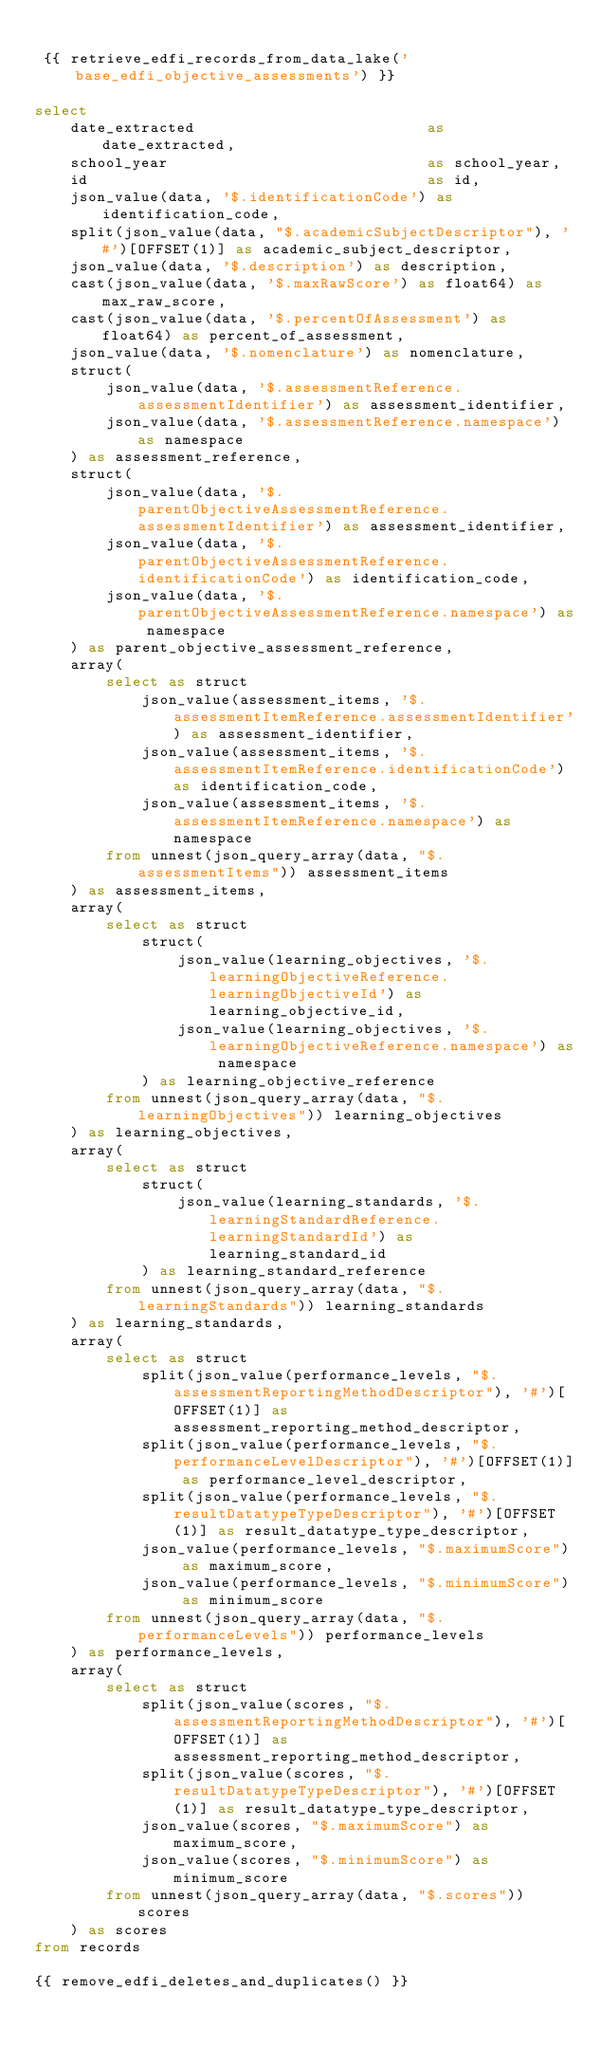Convert code to text. <code><loc_0><loc_0><loc_500><loc_500><_SQL_>
 {{ retrieve_edfi_records_from_data_lake('base_edfi_objective_assessments') }}

select
    date_extracted                          as date_extracted,
    school_year                             as school_year,
    id                                      as id,
    json_value(data, '$.identificationCode') as identification_code,
    split(json_value(data, "$.academicSubjectDescriptor"), '#')[OFFSET(1)] as academic_subject_descriptor,
    json_value(data, '$.description') as description,
    cast(json_value(data, '$.maxRawScore') as float64) as max_raw_score,
    cast(json_value(data, '$.percentOfAssessment') as float64) as percent_of_assessment,
    json_value(data, '$.nomenclature') as nomenclature,
    struct(
        json_value(data, '$.assessmentReference.assessmentIdentifier') as assessment_identifier,
        json_value(data, '$.assessmentReference.namespace') as namespace
    ) as assessment_reference,
    struct(
        json_value(data, '$.parentObjectiveAssessmentReference.assessmentIdentifier') as assessment_identifier,
        json_value(data, '$.parentObjectiveAssessmentReference.identificationCode') as identification_code,
        json_value(data, '$.parentObjectiveAssessmentReference.namespace') as namespace
    ) as parent_objective_assessment_reference,
    array(
        select as struct 
            json_value(assessment_items, '$.assessmentItemReference.assessmentIdentifier') as assessment_identifier,
            json_value(assessment_items, '$.assessmentItemReference.identificationCode') as identification_code,
            json_value(assessment_items, '$.assessmentItemReference.namespace') as namespace
        from unnest(json_query_array(data, "$.assessmentItems")) assessment_items 
    ) as assessment_items,
    array(
        select as struct
            struct(
                json_value(learning_objectives, '$.learningObjectiveReference.learningObjectiveId') as learning_objective_id,
                json_value(learning_objectives, '$.learningObjectiveReference.namespace') as namespace
            ) as learning_objective_reference
        from unnest(json_query_array(data, "$.learningObjectives")) learning_objectives 
    ) as learning_objectives,
    array(
        select as struct
            struct(
                json_value(learning_standards, '$.learningStandardReference.learningStandardId') as learning_standard_id
            ) as learning_standard_reference 
        from unnest(json_query_array(data, "$.learningStandards")) learning_standards
    ) as learning_standards,
    array(
        select as struct 
            split(json_value(performance_levels, "$.assessmentReportingMethodDescriptor"), '#')[OFFSET(1)] as assessment_reporting_method_descriptor,
            split(json_value(performance_levels, "$.performanceLevelDescriptor"), '#')[OFFSET(1)] as performance_level_descriptor,
            split(json_value(performance_levels, "$.resultDatatypeTypeDescriptor"), '#')[OFFSET(1)] as result_datatype_type_descriptor,
            json_value(performance_levels, "$.maximumScore") as maximum_score,
            json_value(performance_levels, "$.minimumScore") as minimum_score
        from unnest(json_query_array(data, "$.performanceLevels")) performance_levels 
    ) as performance_levels,
    array(
        select as struct 
            split(json_value(scores, "$.assessmentReportingMethodDescriptor"), '#')[OFFSET(1)] as assessment_reporting_method_descriptor,
            split(json_value(scores, "$.resultDatatypeTypeDescriptor"), '#')[OFFSET(1)] as result_datatype_type_descriptor,
            json_value(scores, "$.maximumScore") as maximum_score,
            json_value(scores, "$.minimumScore") as minimum_score
        from unnest(json_query_array(data, "$.scores")) scores 
    ) as scores
from records

{{ remove_edfi_deletes_and_duplicates() }}
</code> 